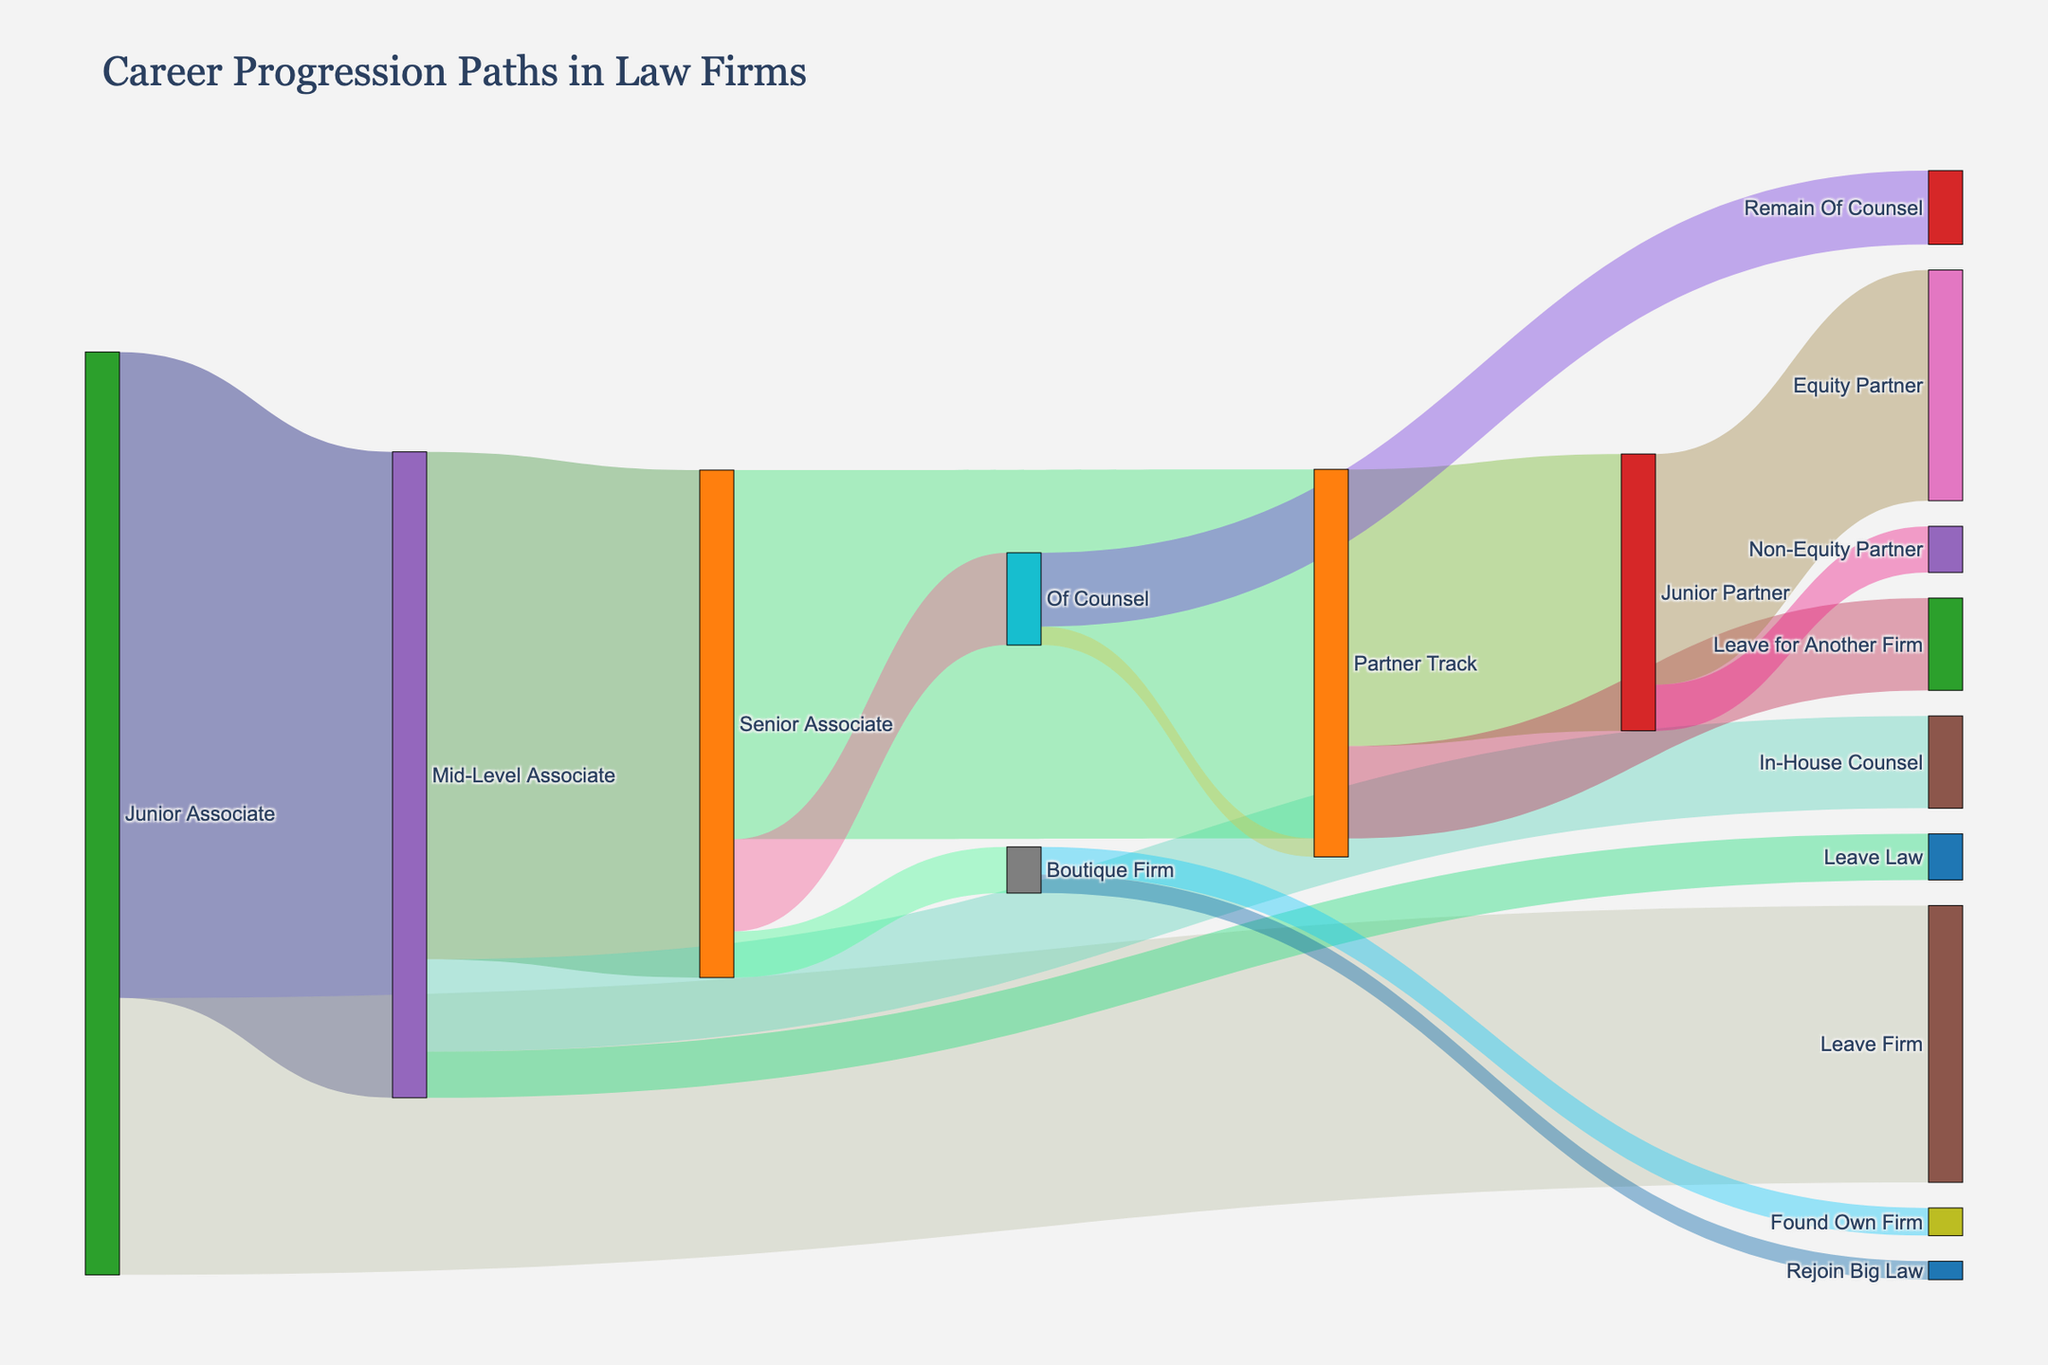How many career paths transition directly from Junior Associate? Identify the distinct transitions originating from Junior Associate in the Sankey diagram. There are transitions to Mid-Level Associate and Leave Firm.
Answer: 2 Which career stage do most Junior Associates progress to, Mid-Level Associate or Leave Firm? Compare the values of the transitions from Junior Associate to Mid-Level Associate (70) and Leave Firm (30).
Answer: Mid-Level Associate What is the total number of Junior Associates who leave the law industry after transitioning to Mid-Level Associate? Sum the values for all transitions from Mid-Level Associate: In-House Counsel (10) and Leave Law (5).
Answer: 15 Are there more individuals progressing to Partner Track from Senior Associate or those remaining as Of Counsel from Senior Associate? Compare the values of the transitions from Senior Associate to Partner Track (40) and from Senior Associate to Of Counsel (10).
Answer: Partner Track How many distinct career transitions lead to the Junior Partner stage? Count the unique stages that have transitions to Junior Partner: Partner Track (30). There is only one transition to Junior Partner.
Answer: 1 What is the combined number of associates who take paths that do not lead to a partner position, starting from the Junior Associate stage? Sum the values for transitions excluding paths directly leading to Partner: Leave Firm (30), In-House Counsel (10), Leave Law (5), Of Counsel (10), Boutique Firm (5).
Answer: 60 How many individuals does the Partner Track accumulate before any leave or transition from this stage? Add the values of all transitions leading to Partner Track: Senior Associate to Partner Track (40) + Of Counsel to Partner Track (2).
Answer: 42 Which transition has the smallest number of individuals moving to the next stage? Compare the values of all transitions and identify the smallest, which is Boutique Firm to Rejoin Big Law (2).
Answer: Boutique Firm to Rejoin Big Law Name the stages where fewer than 10 individuals make a direct transition to another stage. Identify transitions with values less than 10: Mid-Level Associate to Leave Law (5), Senior Associate to Boutique Firm (5), Junior Partner to Non-Equity Partner (5), Of Counsel to Partner Track (2), Of Counsel to Remain Of Counsel (8), Boutique Firm to Found Own Firm (3), Boutique Firm to Rejoin Big Law (2).
Answer: Mid-Level Associate to Leave Law, Senior Associate to Boutique Firm, Junior Partner to Non-Equity Partner, Of Counsel to Partner Track, Of Counsel to Remain Of Counsel, Boutique Firm to Found Own Firm, Boutique Firm to Rejoin Big Law 